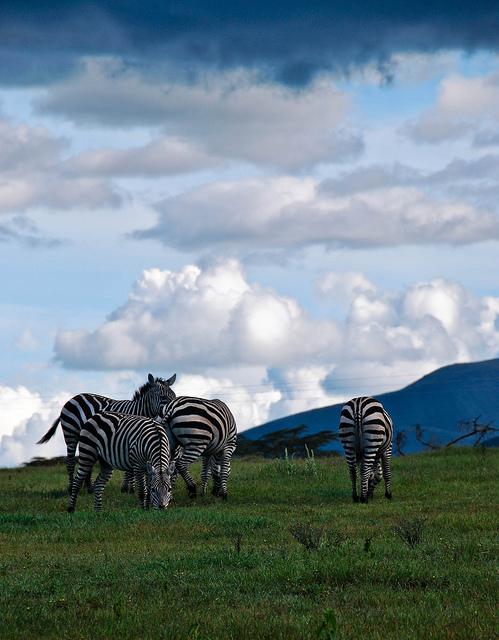Are these domesticated animals?
Keep it brief. No. How many birds are seen?
Write a very short answer. 0. What are the animals eating?
Answer briefly. Grass. 